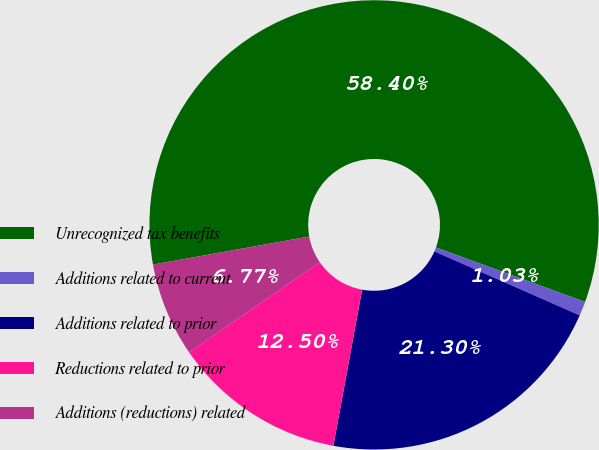<chart> <loc_0><loc_0><loc_500><loc_500><pie_chart><fcel>Unrecognized tax benefits<fcel>Additions related to current<fcel>Additions related to prior<fcel>Reductions related to prior<fcel>Additions (reductions) related<nl><fcel>58.4%<fcel>1.03%<fcel>21.3%<fcel>12.5%<fcel>6.77%<nl></chart> 